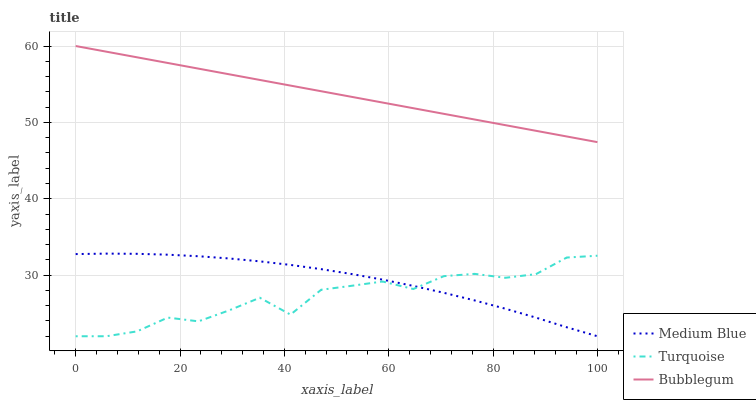Does Medium Blue have the minimum area under the curve?
Answer yes or no. No. Does Medium Blue have the maximum area under the curve?
Answer yes or no. No. Is Medium Blue the smoothest?
Answer yes or no. No. Is Medium Blue the roughest?
Answer yes or no. No. Does Bubblegum have the lowest value?
Answer yes or no. No. Does Medium Blue have the highest value?
Answer yes or no. No. Is Turquoise less than Bubblegum?
Answer yes or no. Yes. Is Bubblegum greater than Medium Blue?
Answer yes or no. Yes. Does Turquoise intersect Bubblegum?
Answer yes or no. No. 